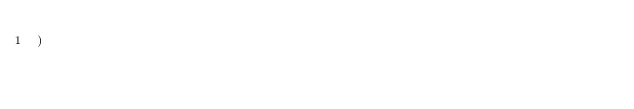<code> <loc_0><loc_0><loc_500><loc_500><_Python_>)
</code> 